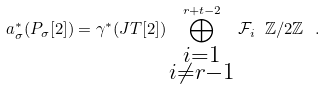Convert formula to latex. <formula><loc_0><loc_0><loc_500><loc_500>a _ { \sigma } ^ { * } ( P _ { \sigma } [ 2 ] ) = \gamma ^ { * } ( J T [ 2 ] ) \bigoplus _ { \substack { i = 1 \\ i \neq r - 1 } } ^ { r + t - 2 } { \mathcal { F } } _ { i } \ { \mathbb { Z } } / 2 { \mathbb { Z } } \ .</formula> 